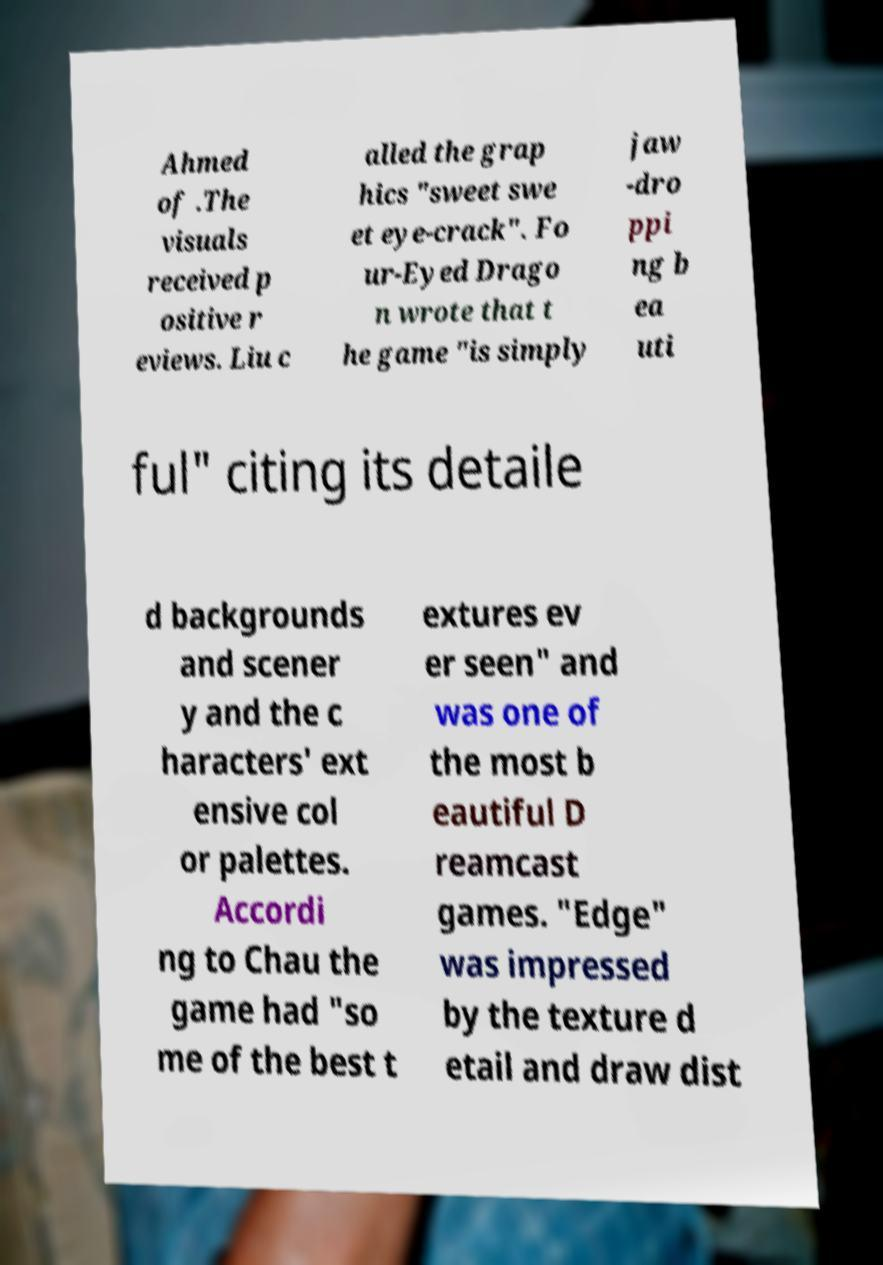Could you assist in decoding the text presented in this image and type it out clearly? Ahmed of .The visuals received p ositive r eviews. Liu c alled the grap hics "sweet swe et eye-crack". Fo ur-Eyed Drago n wrote that t he game "is simply jaw -dro ppi ng b ea uti ful" citing its detaile d backgrounds and scener y and the c haracters' ext ensive col or palettes. Accordi ng to Chau the game had "so me of the best t extures ev er seen" and was one of the most b eautiful D reamcast games. "Edge" was impressed by the texture d etail and draw dist 